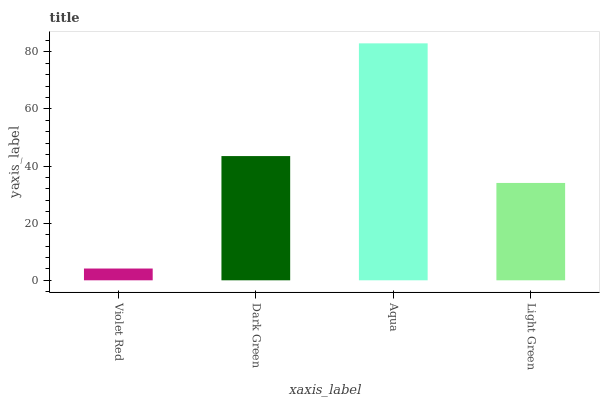Is Violet Red the minimum?
Answer yes or no. Yes. Is Aqua the maximum?
Answer yes or no. Yes. Is Dark Green the minimum?
Answer yes or no. No. Is Dark Green the maximum?
Answer yes or no. No. Is Dark Green greater than Violet Red?
Answer yes or no. Yes. Is Violet Red less than Dark Green?
Answer yes or no. Yes. Is Violet Red greater than Dark Green?
Answer yes or no. No. Is Dark Green less than Violet Red?
Answer yes or no. No. Is Dark Green the high median?
Answer yes or no. Yes. Is Light Green the low median?
Answer yes or no. Yes. Is Violet Red the high median?
Answer yes or no. No. Is Dark Green the low median?
Answer yes or no. No. 